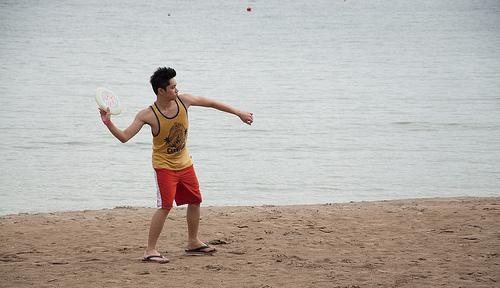Provide a general description of the key elements in the image. A man wearing a yellow tank top and red shorts is playing with a frisbee on the beach, with calm ocean water and sand visible in the background. Mention a specific detail about the man's outfit and the frisbee. The man has a black outline design on his yellow shirt and is holding a white frisbee in his hand. Write an action-driven sentence about the man and his surroundings. A man on the beach is playing frisbee, surrounded by footprints all over the sand and the calm waters behind him. Describe the attire of the man in the image. The man is wearing a yellow tank top with black trim, red and white shorts with a white stripe, and flip flops. Describe one sports element and one accessory worn by the man in the image. The man is throwing a white frisbee and wearing a red band on his wrist as an accessory. Describe the man's appearance from his hair to his footwear. The man has black hair, wears a yellow tank top and red shorts, and is donning flip flops on his feet. Briefly explain the man's footwear and a contrasting statement. The man is wearing flip flops, although he could be wearing shoes or sandals instead. Give a brief description of the location shown in the image. The scene takes place on a sandy beach with calm water in the background, where the sand and water meet. Provide details about the ocean water, beach, and ground in the image. The image showcases a calm water field, blue-green ocean water, tan sand on the beach, and dirt ground by the water. Give a short, poetic description of the scene in the image. A man, clad in colors bright, plays with a frisbee by the shore, where soft sand and gentle waters unite. 